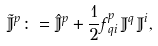<formula> <loc_0><loc_0><loc_500><loc_500>\tilde { \mathbb { J } } ^ { p } \colon = \hat { \mathbb { J } } ^ { p } + \frac { 1 } { 2 } f _ { \, q i } ^ { p } \, \mathbb { J } ^ { q } \, \mathbb { J } ^ { i } ,</formula> 